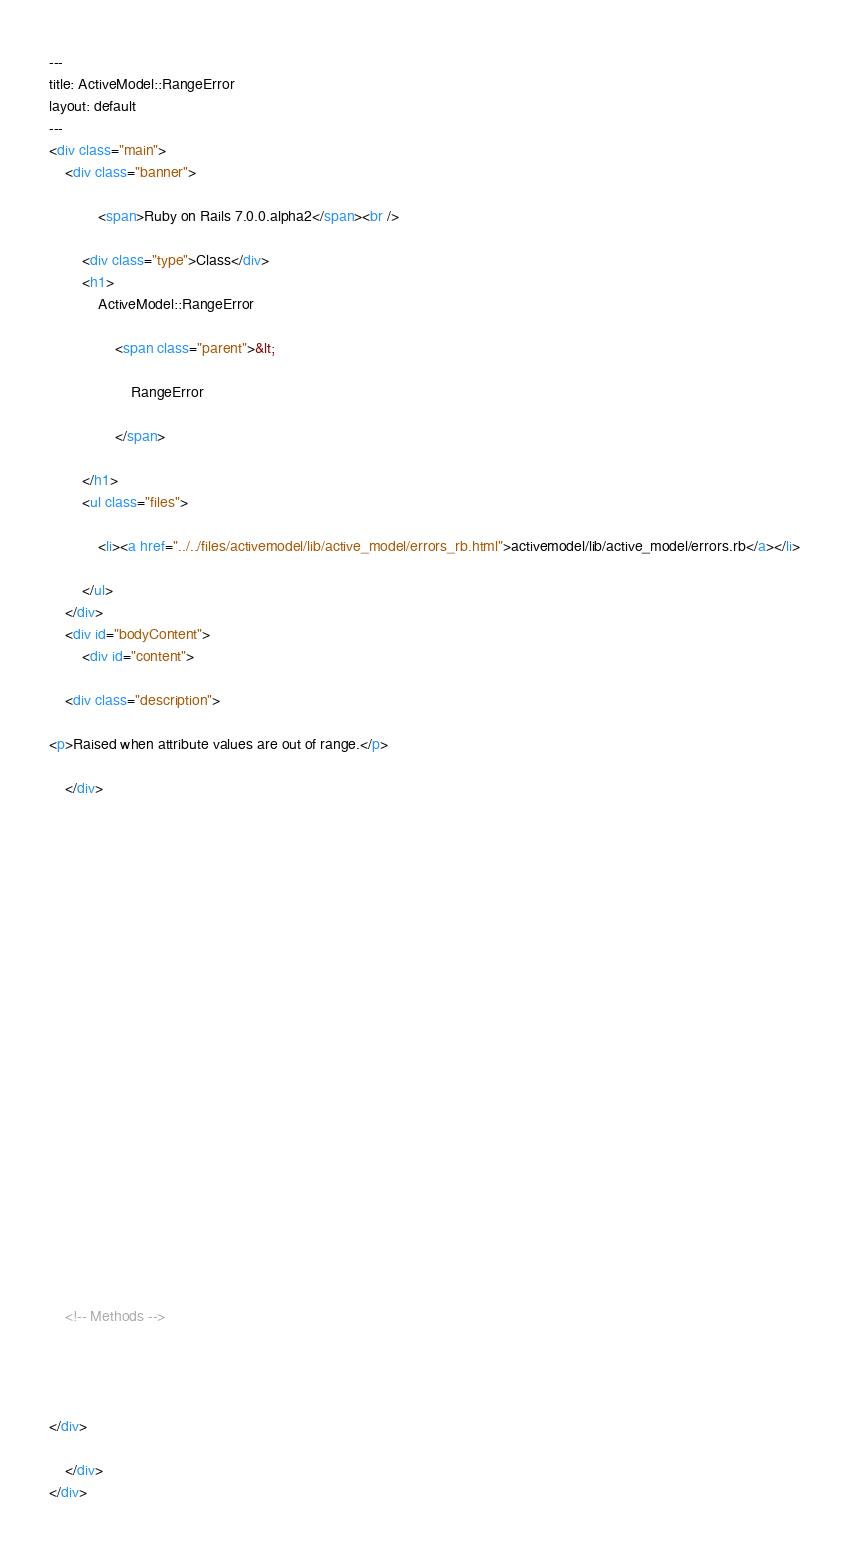<code> <loc_0><loc_0><loc_500><loc_500><_HTML_>---
title: ActiveModel::RangeError
layout: default
---
<div class="main">
    <div class="banner">
        
            <span>Ruby on Rails 7.0.0.alpha2</span><br />
        
        <div class="type">Class</div>
        <h1>
            ActiveModel::RangeError
            
                <span class="parent">&lt;
                    
                    RangeError
                    
                </span>
            
        </h1>
        <ul class="files">
            
            <li><a href="../../files/activemodel/lib/active_model/errors_rb.html">activemodel/lib/active_model/errors.rb</a></li>
            
        </ul>
    </div>
    <div id="bodyContent">
        <div id="content">
  
    <div class="description">
      
<p>Raised when attribute values are out of range.</p>

    </div>
  

  

  
  


  

  

  

  
    

    

    

    

    <!-- Methods -->
    
    
    
  
</div>

    </div>
</div>
</code> 